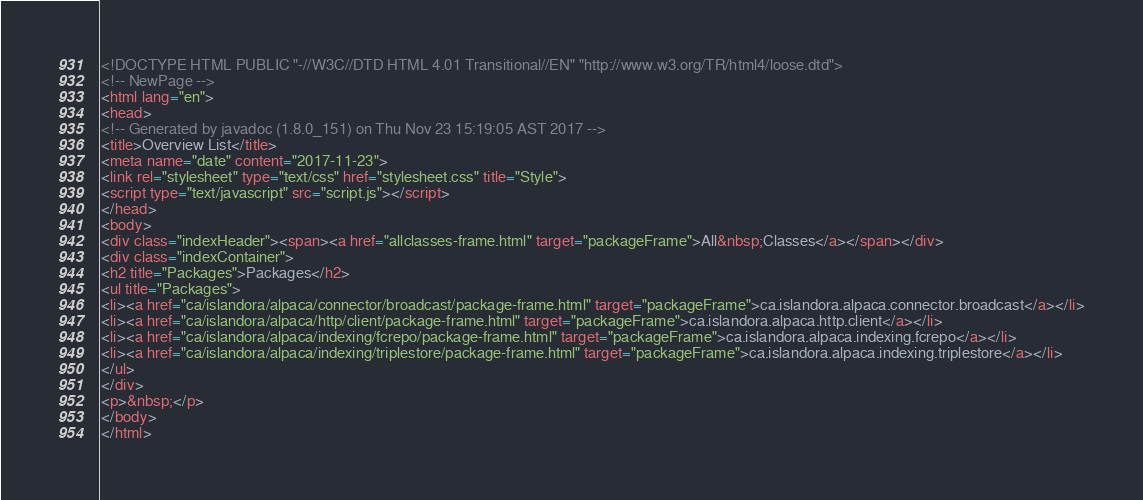<code> <loc_0><loc_0><loc_500><loc_500><_HTML_><!DOCTYPE HTML PUBLIC "-//W3C//DTD HTML 4.01 Transitional//EN" "http://www.w3.org/TR/html4/loose.dtd">
<!-- NewPage -->
<html lang="en">
<head>
<!-- Generated by javadoc (1.8.0_151) on Thu Nov 23 15:19:05 AST 2017 -->
<title>Overview List</title>
<meta name="date" content="2017-11-23">
<link rel="stylesheet" type="text/css" href="stylesheet.css" title="Style">
<script type="text/javascript" src="script.js"></script>
</head>
<body>
<div class="indexHeader"><span><a href="allclasses-frame.html" target="packageFrame">All&nbsp;Classes</a></span></div>
<div class="indexContainer">
<h2 title="Packages">Packages</h2>
<ul title="Packages">
<li><a href="ca/islandora/alpaca/connector/broadcast/package-frame.html" target="packageFrame">ca.islandora.alpaca.connector.broadcast</a></li>
<li><a href="ca/islandora/alpaca/http/client/package-frame.html" target="packageFrame">ca.islandora.alpaca.http.client</a></li>
<li><a href="ca/islandora/alpaca/indexing/fcrepo/package-frame.html" target="packageFrame">ca.islandora.alpaca.indexing.fcrepo</a></li>
<li><a href="ca/islandora/alpaca/indexing/triplestore/package-frame.html" target="packageFrame">ca.islandora.alpaca.indexing.triplestore</a></li>
</ul>
</div>
<p>&nbsp;</p>
</body>
</html>
</code> 